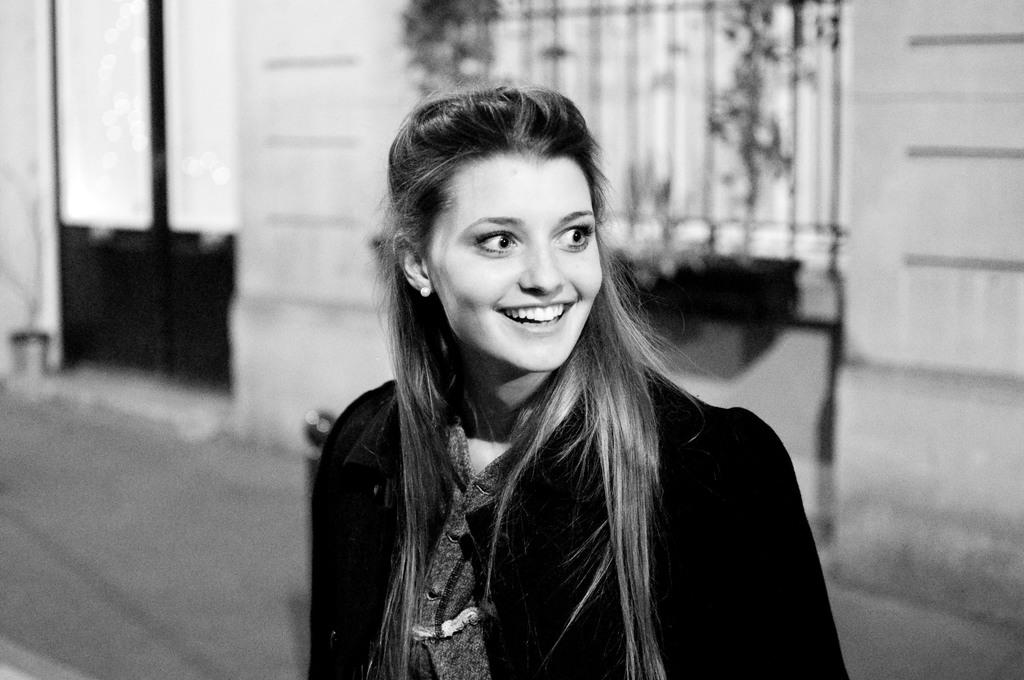What is the color scheme of the image? The image is black and white. Who or what is in the middle of the image? There is a girl standing in the middle of the image. What can be seen in the background of the image? There is a building in the background of the image. Where is the door located in the image? There is a door on the left side of the image. Can you see a tiger walking on the road in the image? No, there is no tiger or road present in the image. What type of cup is the girl holding in the image? There is no cup visible in the image; the girl is not holding anything. 